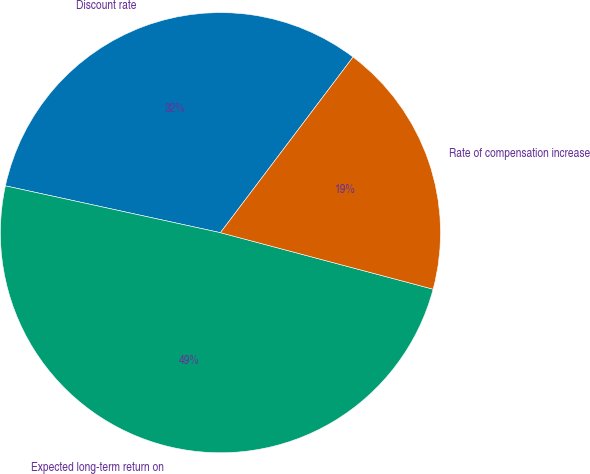Convert chart to OTSL. <chart><loc_0><loc_0><loc_500><loc_500><pie_chart><fcel>Discount rate<fcel>Expected long-term return on<fcel>Rate of compensation increase<nl><fcel>31.88%<fcel>49.28%<fcel>18.84%<nl></chart> 